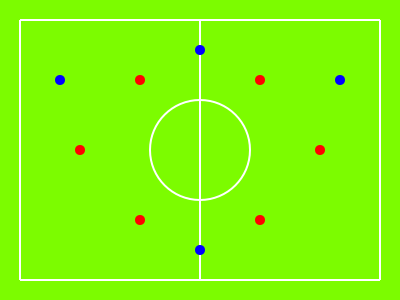In the diagram above, which tactical formation is represented by the red dots, and what potential weakness does this formation have against the blue team's setup? To analyze this tactical formation, let's follow these steps:

1. Identify the formation:
   The red dots represent 6 players on the field.
   Their positioning forms two lines: 4 players in a diamond shape and 2 players behind them.
   This formation is known as the 4-2 formation in futsal or indoor football.

2. Analyze the formation:
   - 4 players form a diamond shape: 2 on the sides, 1 at the top, and 1 at the bottom.
   - 2 players are positioned behind the diamond, likely as defenders.

3. Identify the blue team's setup:
   The blue dots show 5 players spread out widely across the field.
   This suggests a more expansive playing style, possibly a 3-1 or 2-2 formation.

4. Assess the potential weakness:
   The main weakness of the red team's 4-2 formation against the blue team's setup is:
   - Lack of width: The red team's players are concentrated in the center, leaving the wings exposed.
   - The blue team has players positioned wide (at x=60 and x=340), which can exploit this lack of width.
   - This setup allows the blue team to stretch the red team's defense and create spaces for attacking plays.

5. Consequence of the weakness:
   The blue team can use their wide players to:
   - Draw out the red team's defenders, creating gaps in the center.
   - Quickly switch play from one side to another, making it difficult for the red team to shift their compact formation.
   - Create 1v1 situations on the wings, potentially overwhelming the red team's defense.
Answer: 4-2 formation; lack of width against blue team's wide setup 